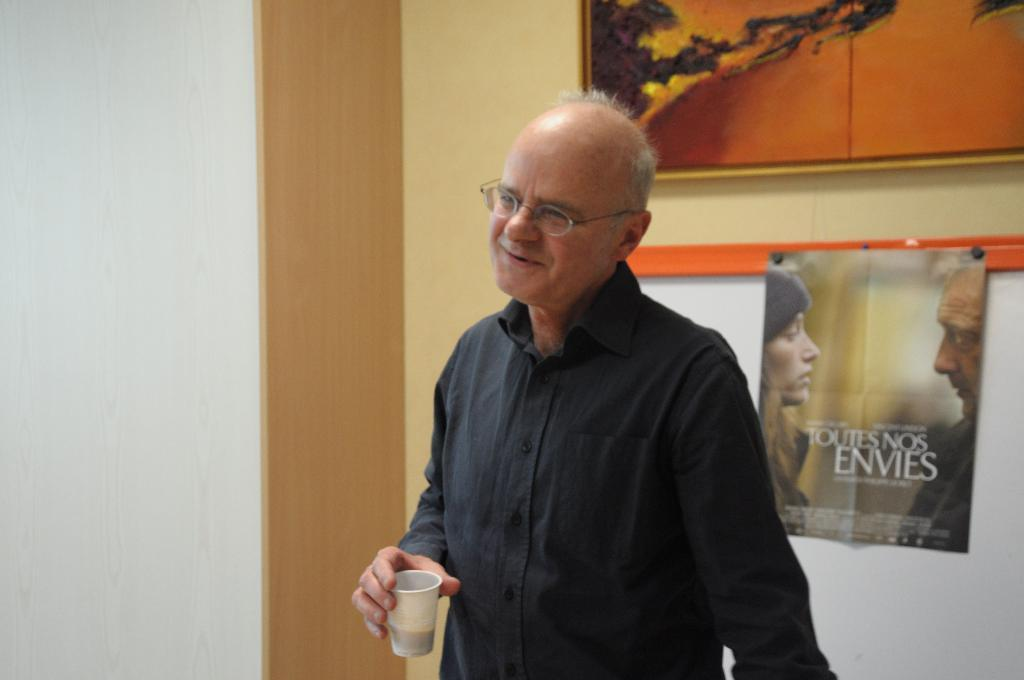What is the main subject of the image? There is a person in the image. What is the person holding in the image? The person is holding a glass. What other objects can be seen in the image? There is a photo frame, a board, and a poster on the board visible in the image. What is the background of the image? There is a wall visible in the image. How many pigs are visible in the image? There are no pigs present in the image. What type of division is shown on the board in the image? There is no division shown on the board in the image; it features a poster. 